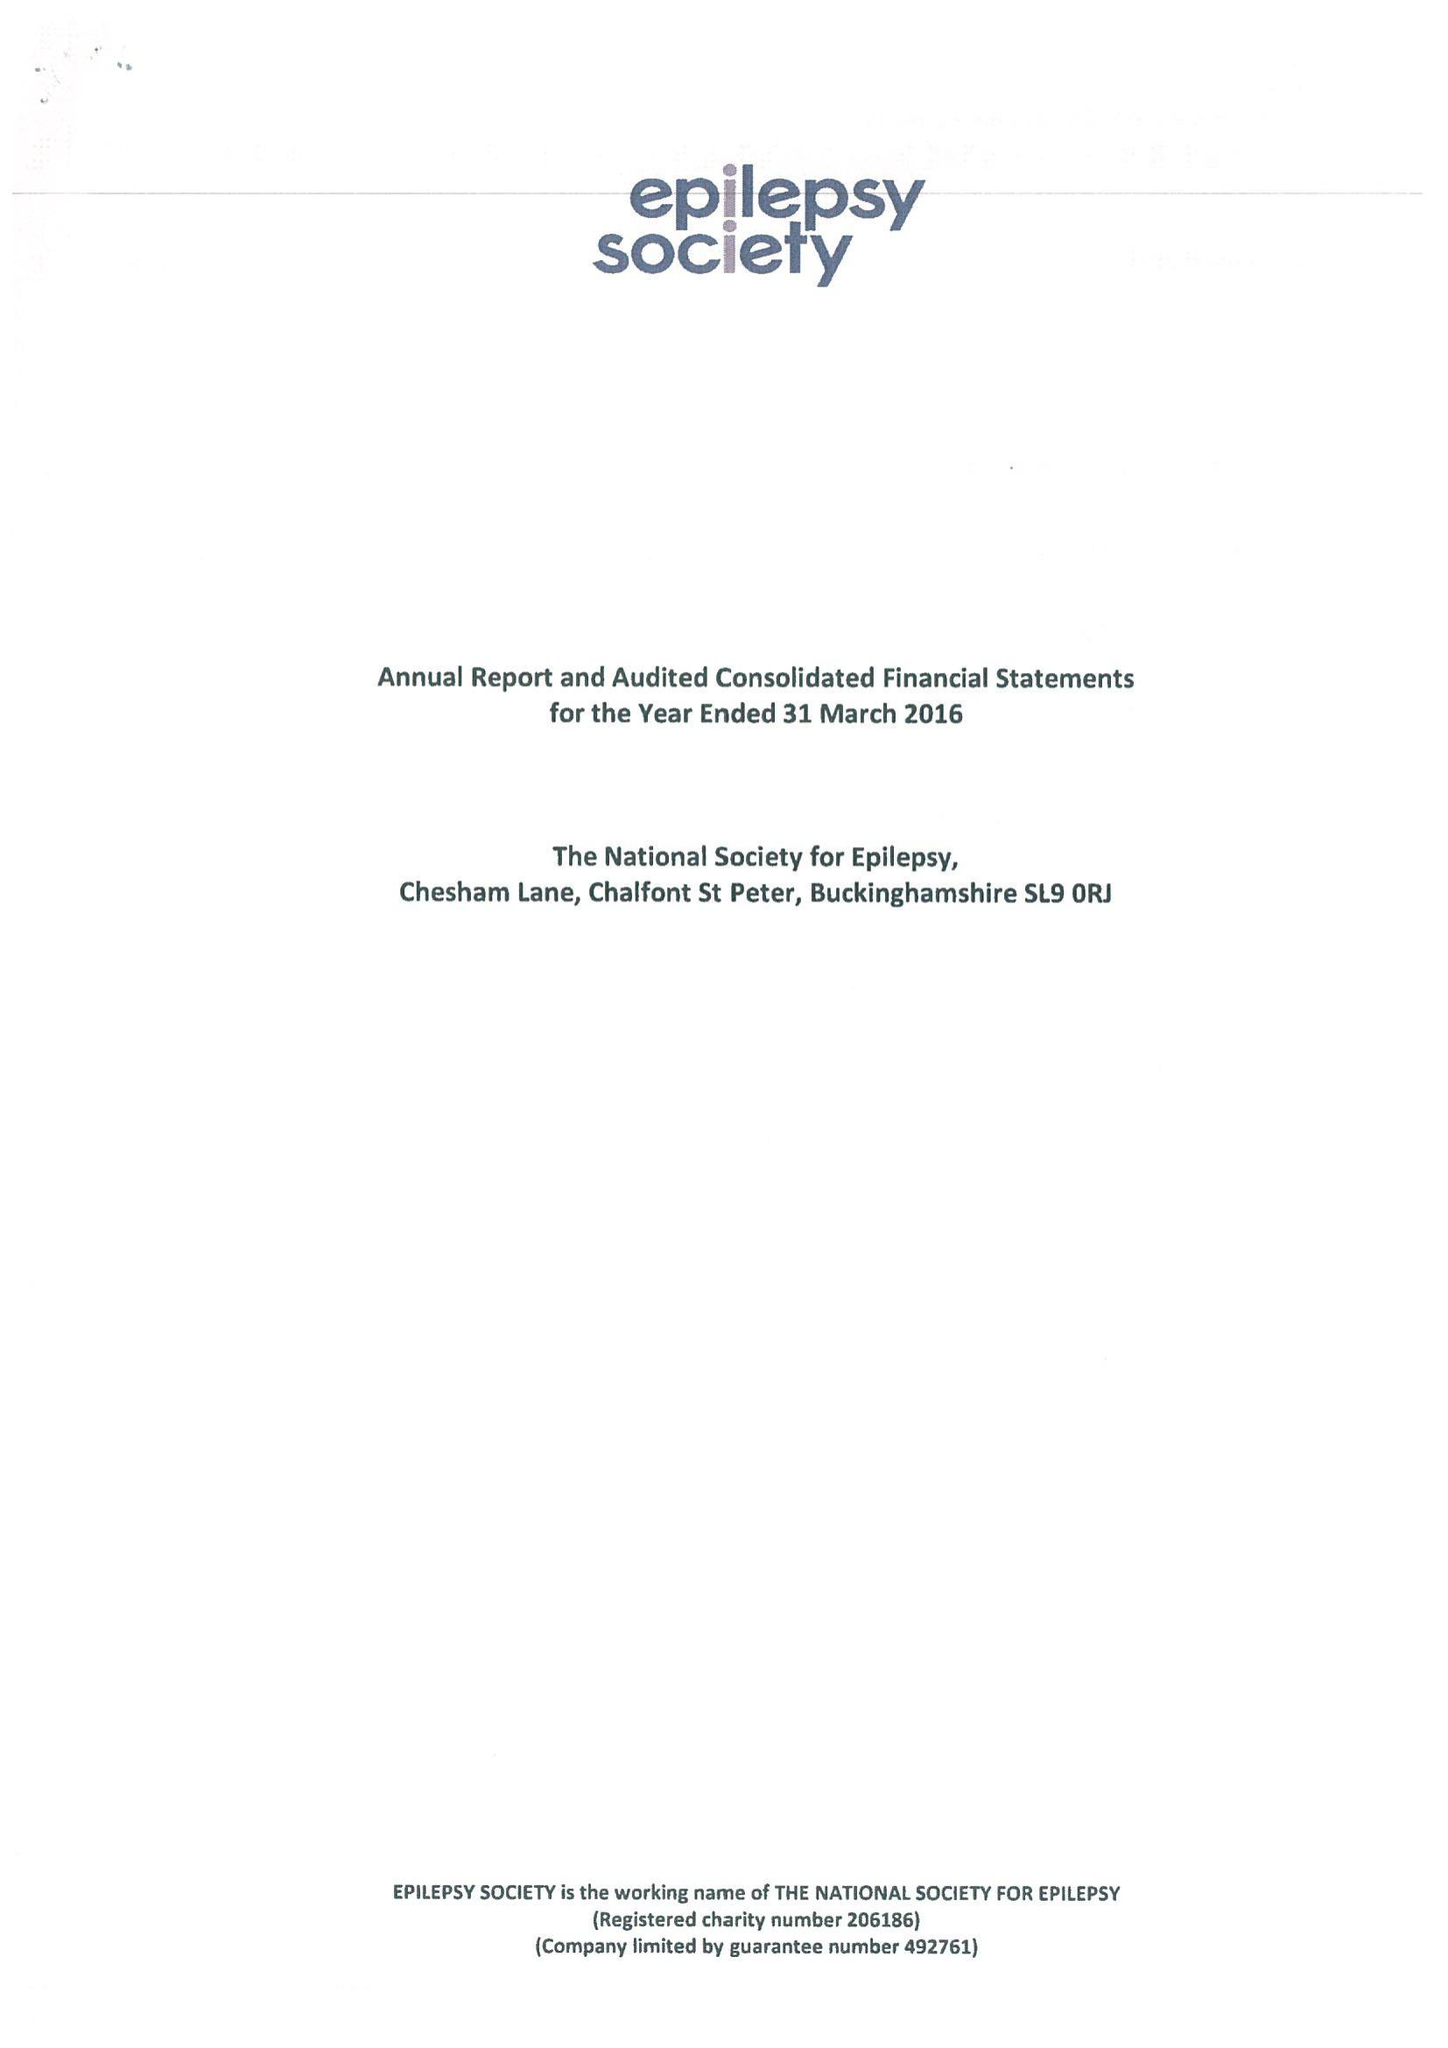What is the value for the address__post_town?
Answer the question using a single word or phrase. GERRARDS CROSS 